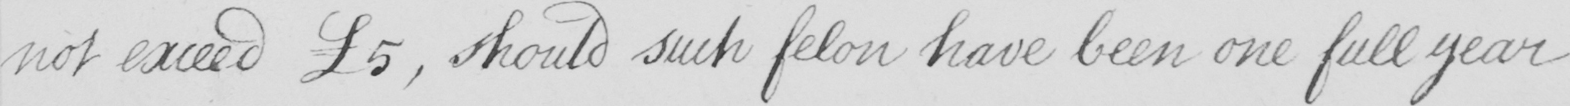Please provide the text content of this handwritten line. not exceed £5 , should such felon have been one full year 